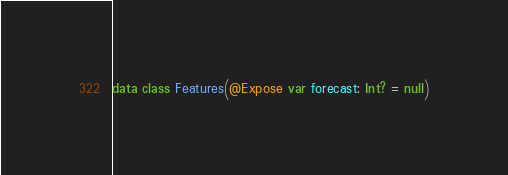<code> <loc_0><loc_0><loc_500><loc_500><_Kotlin_>
data class Features(@Expose var forecast: Int? = null)</code> 